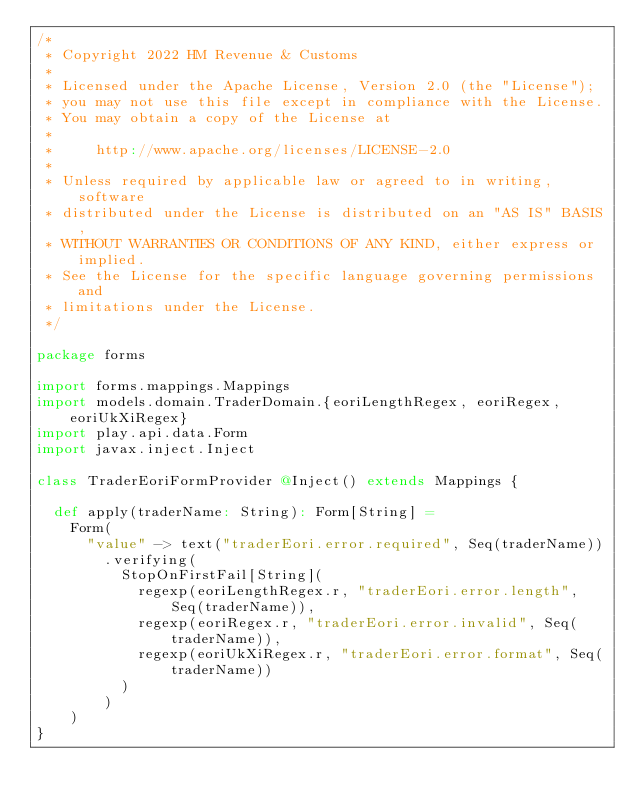Convert code to text. <code><loc_0><loc_0><loc_500><loc_500><_Scala_>/*
 * Copyright 2022 HM Revenue & Customs
 *
 * Licensed under the Apache License, Version 2.0 (the "License");
 * you may not use this file except in compliance with the License.
 * You may obtain a copy of the License at
 *
 *     http://www.apache.org/licenses/LICENSE-2.0
 *
 * Unless required by applicable law or agreed to in writing, software
 * distributed under the License is distributed on an "AS IS" BASIS,
 * WITHOUT WARRANTIES OR CONDITIONS OF ANY KIND, either express or implied.
 * See the License for the specific language governing permissions and
 * limitations under the License.
 */

package forms

import forms.mappings.Mappings
import models.domain.TraderDomain.{eoriLengthRegex, eoriRegex, eoriUkXiRegex}
import play.api.data.Form
import javax.inject.Inject

class TraderEoriFormProvider @Inject() extends Mappings {

  def apply(traderName: String): Form[String] =
    Form(
      "value" -> text("traderEori.error.required", Seq(traderName))
        .verifying(
          StopOnFirstFail[String](
            regexp(eoriLengthRegex.r, "traderEori.error.length", Seq(traderName)),
            regexp(eoriRegex.r, "traderEori.error.invalid", Seq(traderName)),
            regexp(eoriUkXiRegex.r, "traderEori.error.format", Seq(traderName))
          )
        )
    )
}
</code> 